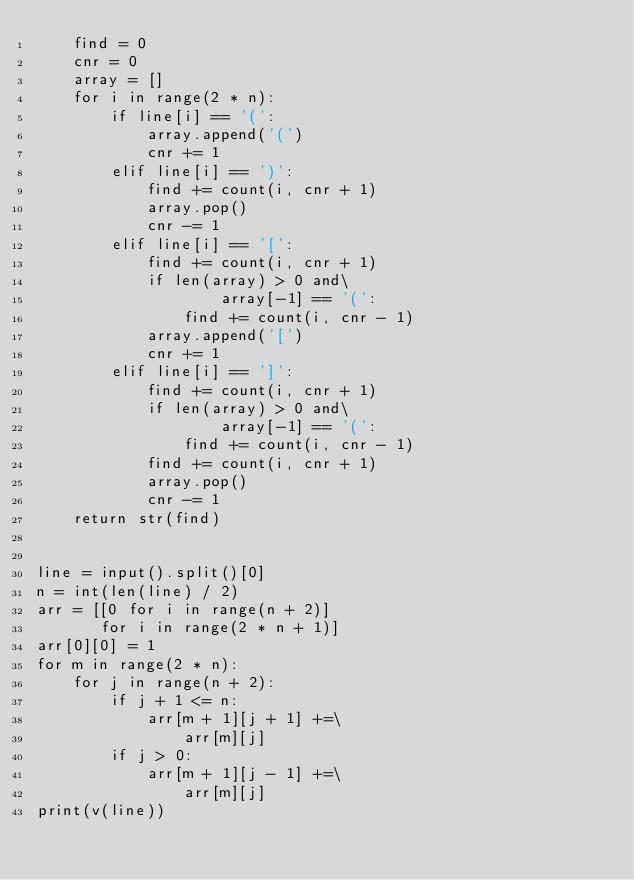Convert code to text. <code><loc_0><loc_0><loc_500><loc_500><_Python_>    find = 0
    cnr = 0
    array = []
    for i in range(2 * n):
        if line[i] == '(':
            array.append('(')
            cnr += 1
        elif line[i] == ')':
            find += count(i, cnr + 1)
            array.pop()
            cnr -= 1
        elif line[i] == '[':
            find += count(i, cnr + 1)
            if len(array) > 0 and\
                    array[-1] == '(':
                find += count(i, cnr - 1)
            array.append('[')
            cnr += 1
        elif line[i] == ']':
            find += count(i, cnr + 1)
            if len(array) > 0 and\
                    array[-1] == '(':
                find += count(i, cnr - 1)
            find += count(i, cnr + 1)
            array.pop()
            cnr -= 1
    return str(find)


line = input().split()[0]
n = int(len(line) / 2)
arr = [[0 for i in range(n + 2)]
       for i in range(2 * n + 1)]
arr[0][0] = 1
for m in range(2 * n):
    for j in range(n + 2):
        if j + 1 <= n:
            arr[m + 1][j + 1] +=\
                arr[m][j]
        if j > 0:
            arr[m + 1][j - 1] +=\
                arr[m][j]
print(v(line))
</code> 